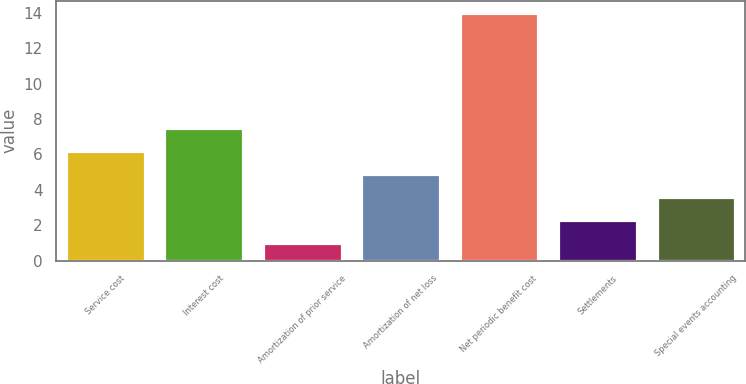<chart> <loc_0><loc_0><loc_500><loc_500><bar_chart><fcel>Service cost<fcel>Interest cost<fcel>Amortization of prior service<fcel>Amortization of net loss<fcel>Net periodic benefit cost<fcel>Settlements<fcel>Special events accounting<nl><fcel>6.2<fcel>7.5<fcel>1<fcel>4.9<fcel>14<fcel>2.3<fcel>3.6<nl></chart> 